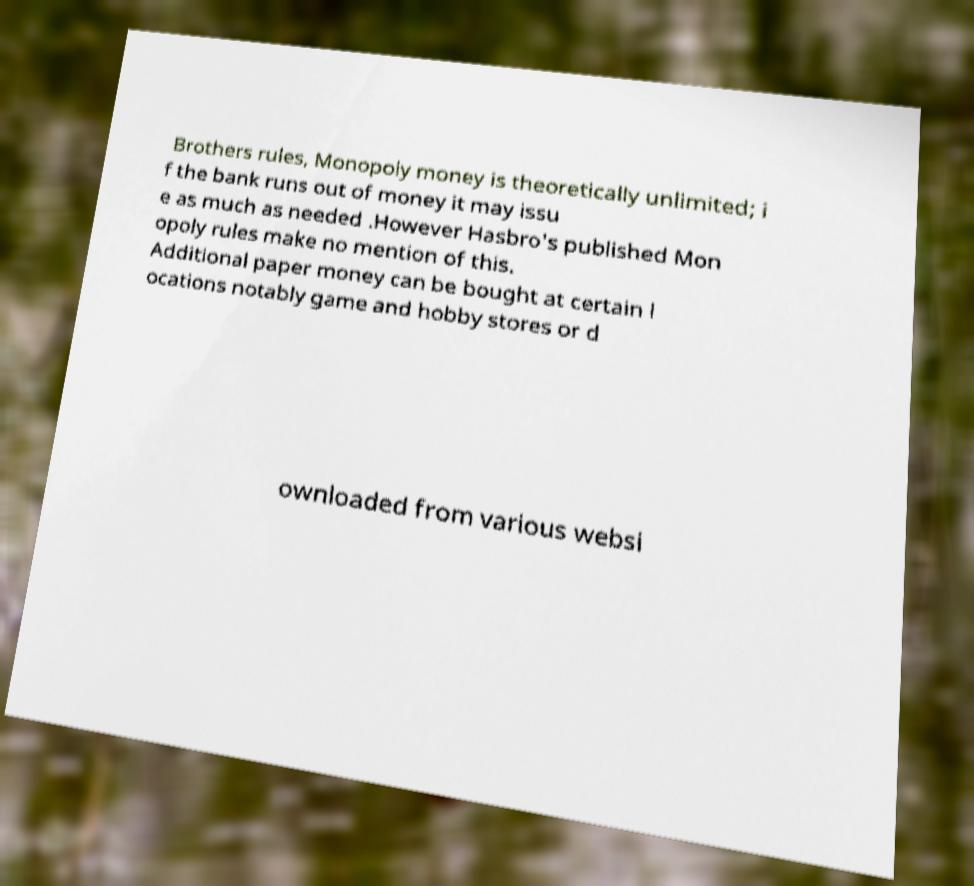There's text embedded in this image that I need extracted. Can you transcribe it verbatim? Brothers rules, Monopoly money is theoretically unlimited; i f the bank runs out of money it may issu e as much as needed .However Hasbro's published Mon opoly rules make no mention of this. Additional paper money can be bought at certain l ocations notably game and hobby stores or d ownloaded from various websi 